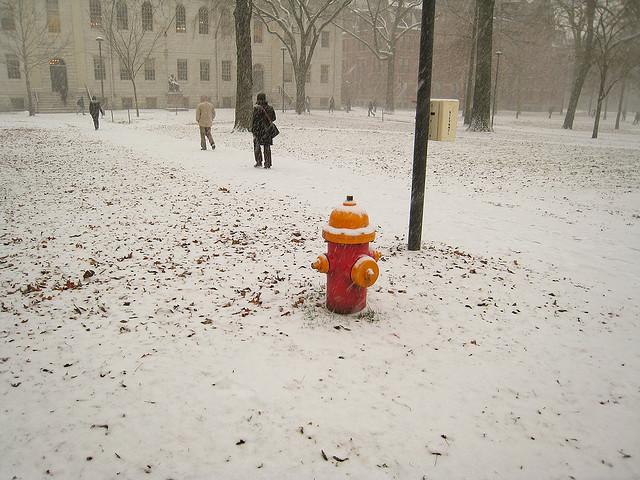Could a fire truck access the hydrant easily?
Short answer required. Yes. What covers the snow?
Keep it brief. Leaves. Is it cold outside?
Keep it brief. Yes. What is the orange object used for?
Keep it brief. Water. 